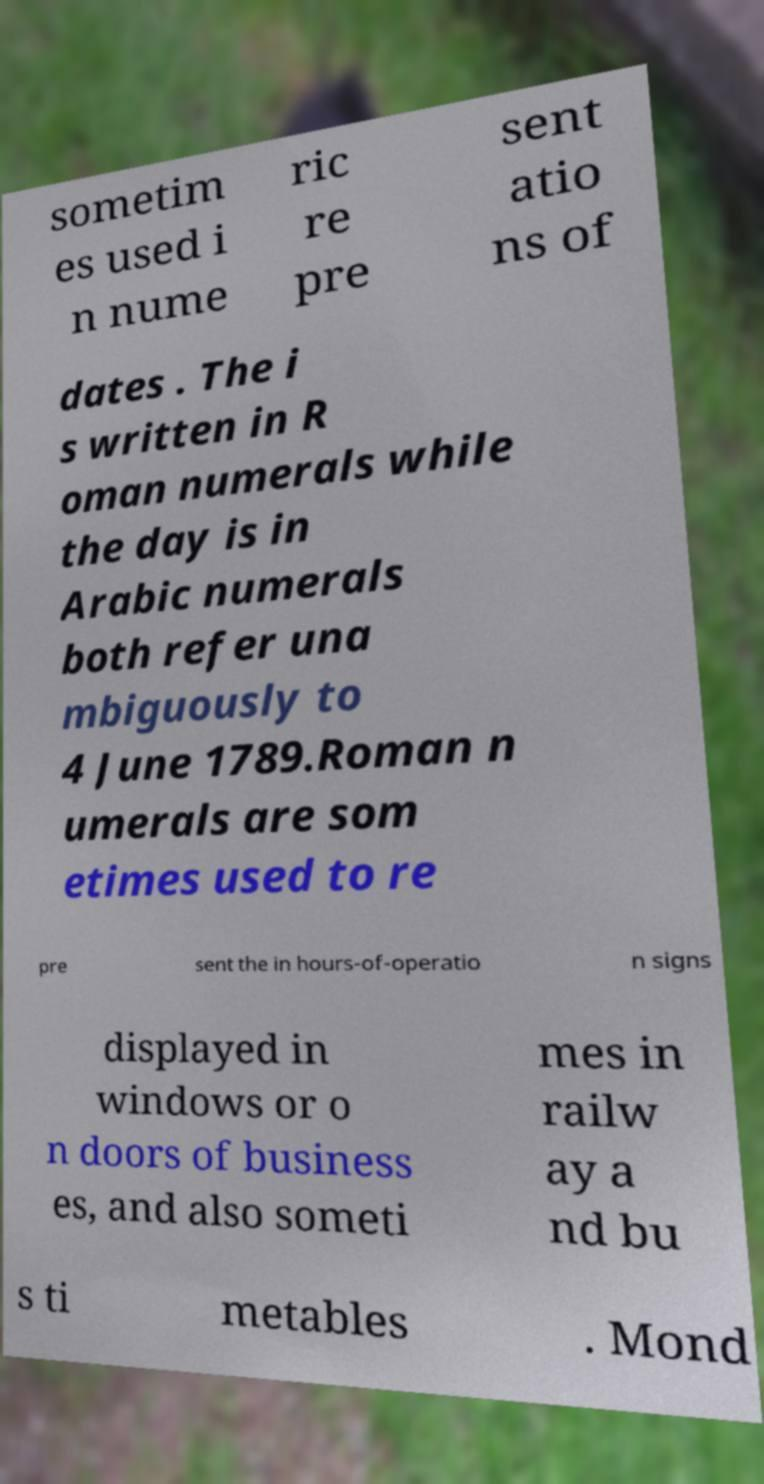Can you read and provide the text displayed in the image?This photo seems to have some interesting text. Can you extract and type it out for me? sometim es used i n nume ric re pre sent atio ns of dates . The i s written in R oman numerals while the day is in Arabic numerals both refer una mbiguously to 4 June 1789.Roman n umerals are som etimes used to re pre sent the in hours-of-operatio n signs displayed in windows or o n doors of business es, and also someti mes in railw ay a nd bu s ti metables . Mond 